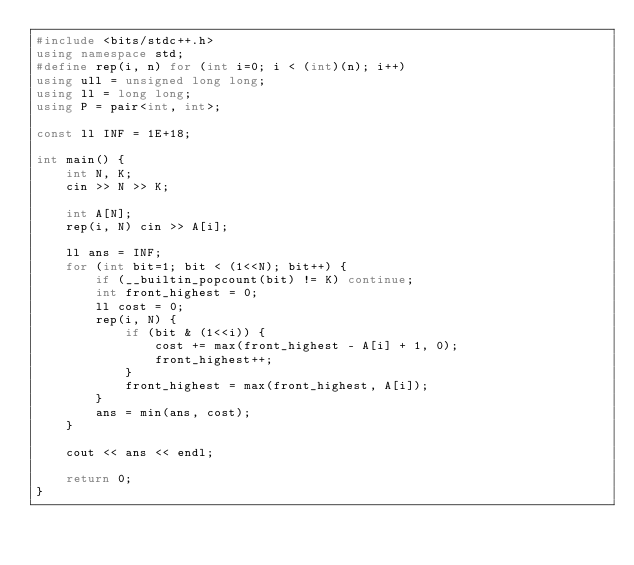<code> <loc_0><loc_0><loc_500><loc_500><_C++_>#include <bits/stdc++.h>
using namespace std;
#define rep(i, n) for (int i=0; i < (int)(n); i++)
using ull = unsigned long long;
using ll = long long;
using P = pair<int, int>;

const ll INF = 1E+18;

int main() {
    int N, K;
    cin >> N >> K;

    int A[N];
    rep(i, N) cin >> A[i];

    ll ans = INF;
    for (int bit=1; bit < (1<<N); bit++) {
        if (__builtin_popcount(bit) != K) continue;
        int front_highest = 0;
        ll cost = 0;
        rep(i, N) {
            if (bit & (1<<i)) {
                cost += max(front_highest - A[i] + 1, 0);
                front_highest++;
            }
            front_highest = max(front_highest, A[i]);
        }
        ans = min(ans, cost);
    }

    cout << ans << endl;

    return 0;
}</code> 